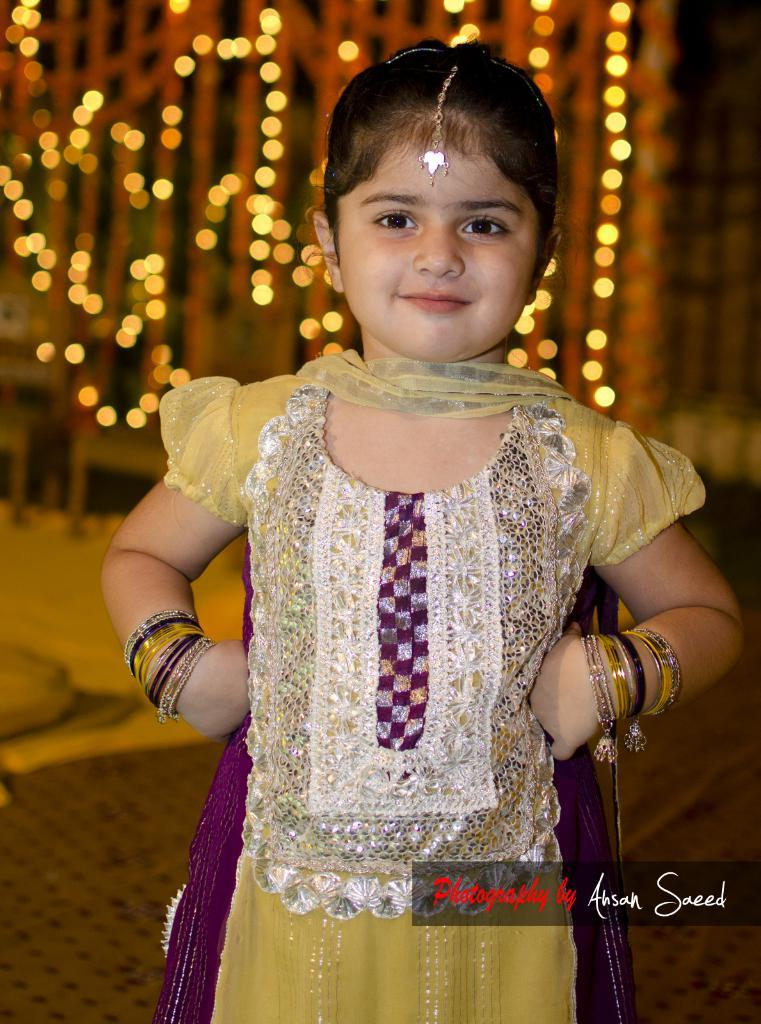What is the main subject of the image? There is a small girl standing in the image. What can be seen in the background of the image? There are lights visible in the background of the image. What type of jewel is the girl wearing around her neck in the image? There is no jewel visible around the girl's neck in the image. How is the hook attached to the girl's clothing in the image? There is no hook present in the image. 